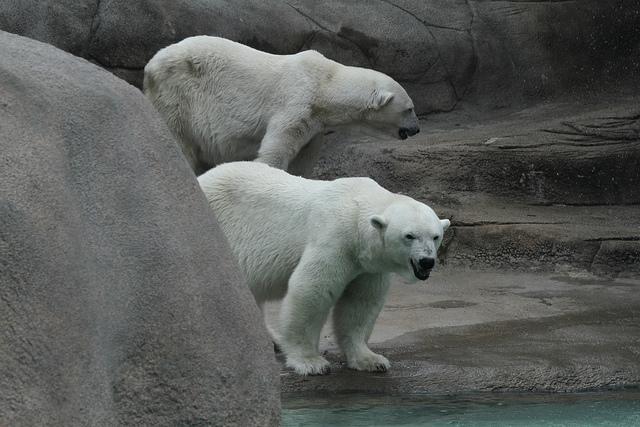Does their environment look natural?
Answer briefly. No. Is this a polar bear couple?
Write a very short answer. Yes. How many polar bears are there?
Quick response, please. 2. What color are the bears?
Give a very brief answer. White. 